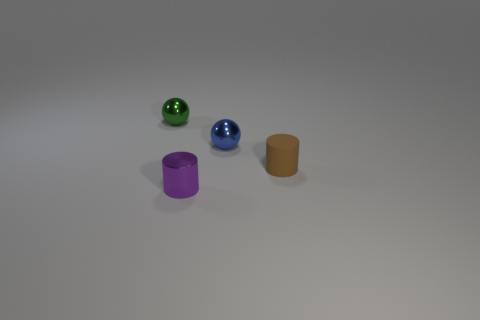What could these objects represent if we think of them as symbolic? Interpreted symbolically, these objects could represent diversity and individuality, with each one having a distinct color and shape. They could also symbolize a range of sizes, illustrating hierarchy or progression, such as stages of growth or levels of importance. 